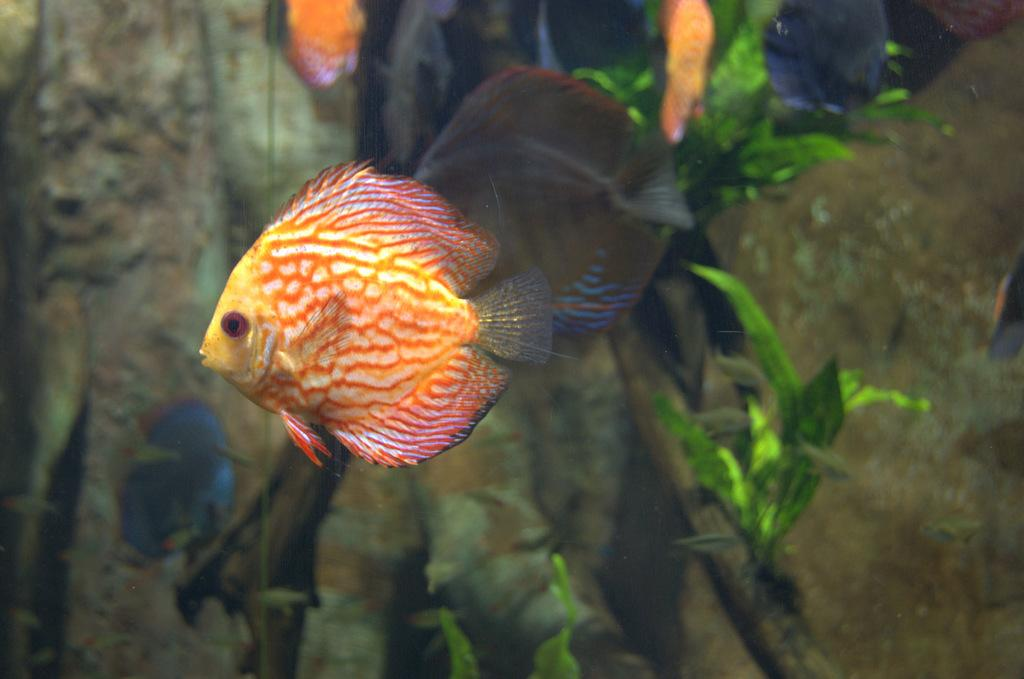What type of animals can be seen in the image? There are many fishes in the image. What other elements are present in the image besides the fishes? There are plants in the image. What type of steel is used to construct the sink in the image? There is no sink or steel present in the image; it features many fishes and plants. How does the love between the fishes manifest in the image? The concept of love is not applicable to the fishes in the image, as they are aquatic animals and not capable of experiencing emotions like love. 